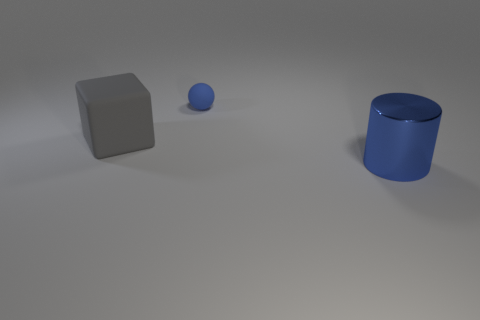What number of objects are behind the large shiny cylinder and in front of the blue ball?
Your response must be concise. 1. Is there anything else that has the same size as the blue rubber thing?
Your answer should be very brief. No. Are there more rubber things on the right side of the gray matte object than tiny matte objects that are to the right of the big cylinder?
Ensure brevity in your answer.  Yes. There is a object that is left of the tiny blue matte sphere; what material is it?
Provide a short and direct response. Rubber. Do the blue rubber object and the big object that is to the right of the big gray block have the same shape?
Keep it short and to the point. No. How many metal cylinders are in front of the large object behind the large thing that is to the right of the gray rubber thing?
Ensure brevity in your answer.  1. Is there anything else that has the same shape as the big blue object?
Offer a terse response. No. How many spheres are large rubber objects or blue objects?
Keep it short and to the point. 1. The large gray thing is what shape?
Your response must be concise. Cube. There is a blue rubber ball; are there any small blue rubber balls behind it?
Offer a terse response. No. 